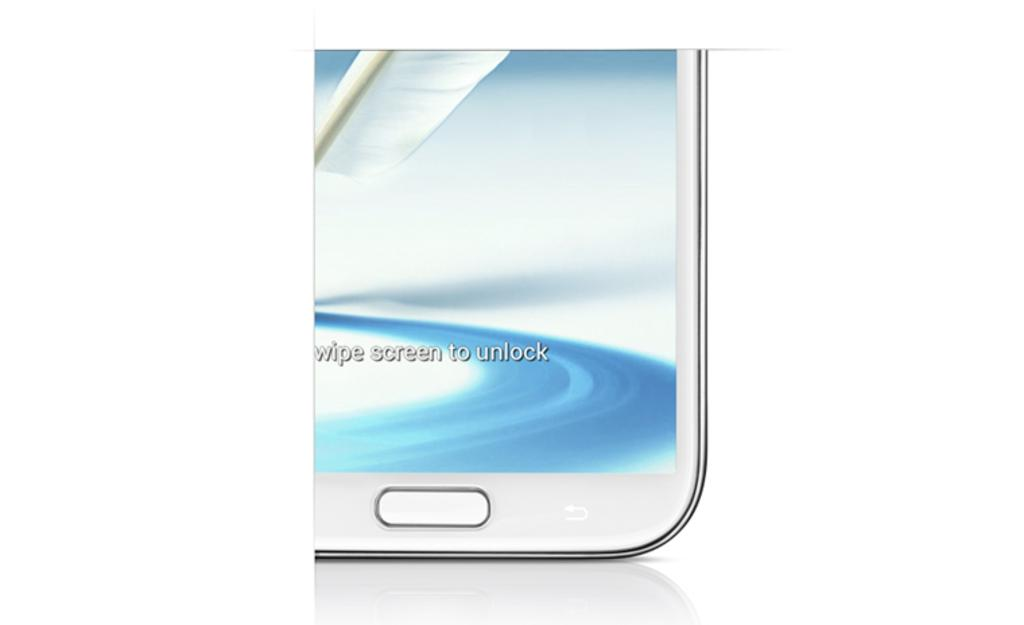<image>
Offer a succinct explanation of the picture presented. a white phone that shows the words 'swipe screen to unlock' on the screen 